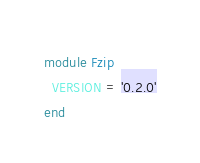<code> <loc_0><loc_0><loc_500><loc_500><_Ruby_>module Fzip
  VERSION = '0.2.0'
end
</code> 